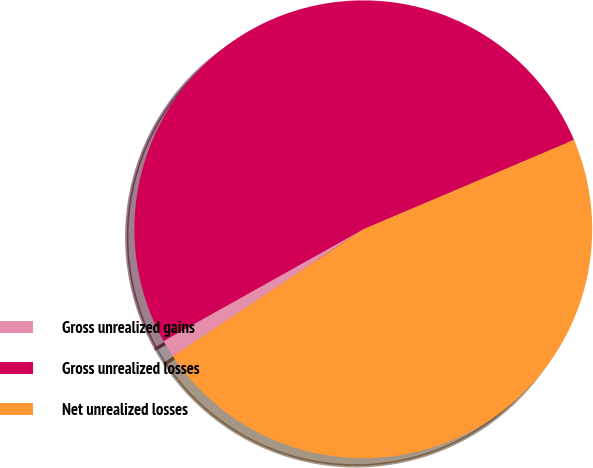Convert chart. <chart><loc_0><loc_0><loc_500><loc_500><pie_chart><fcel>Gross unrealized gains<fcel>Gross unrealized losses<fcel>Net unrealized losses<nl><fcel>1.23%<fcel>51.74%<fcel>47.03%<nl></chart> 